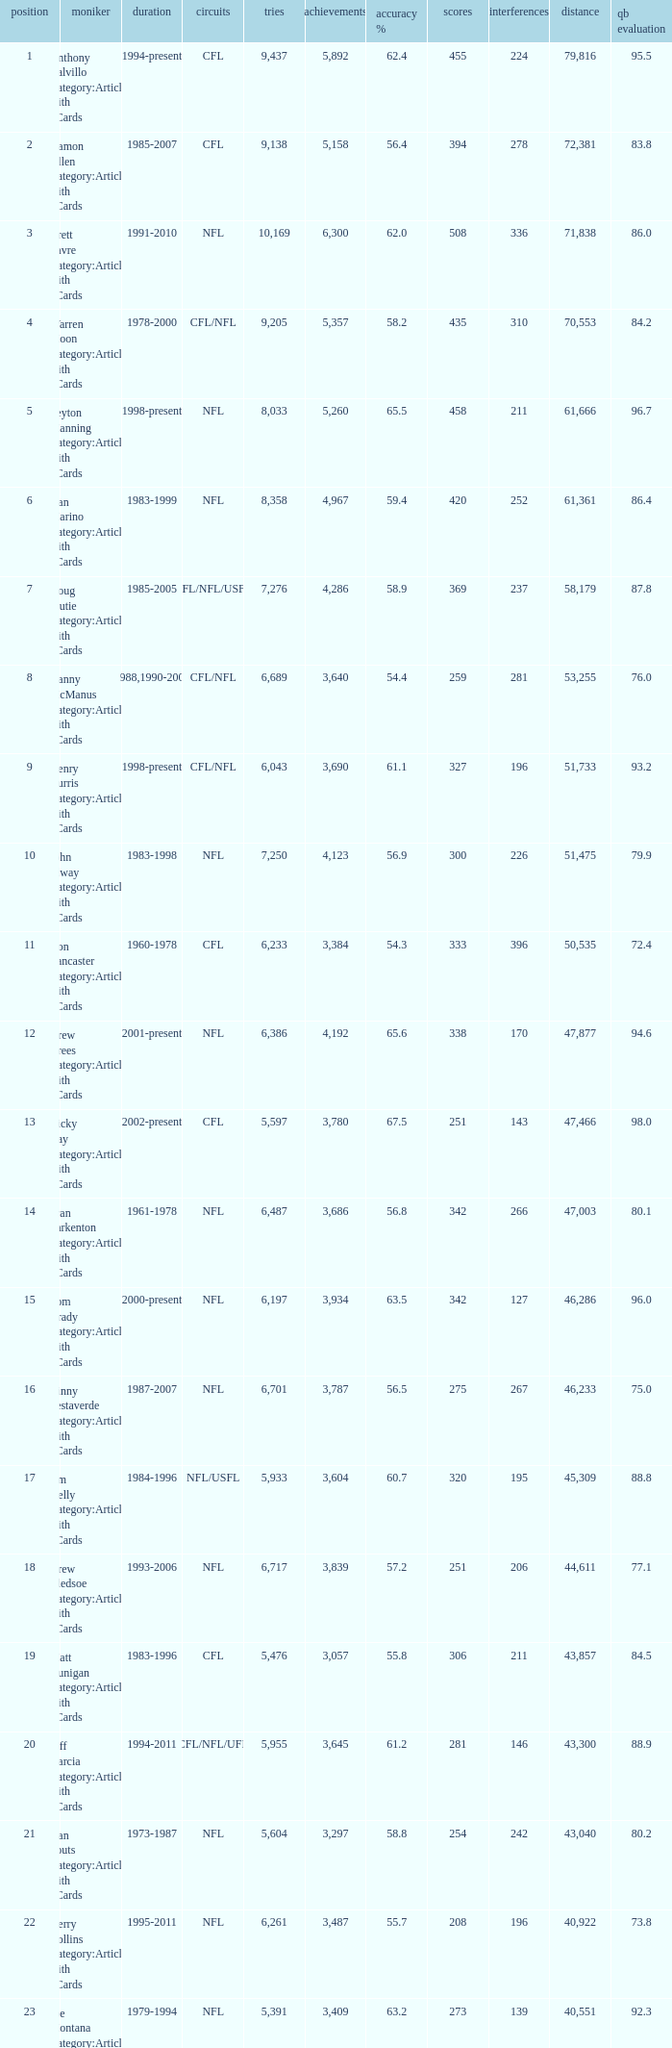What is the number of interceptions with less than 3,487 completions , more than 40,551 yardage, and the comp % is 55.8? 211.0. 